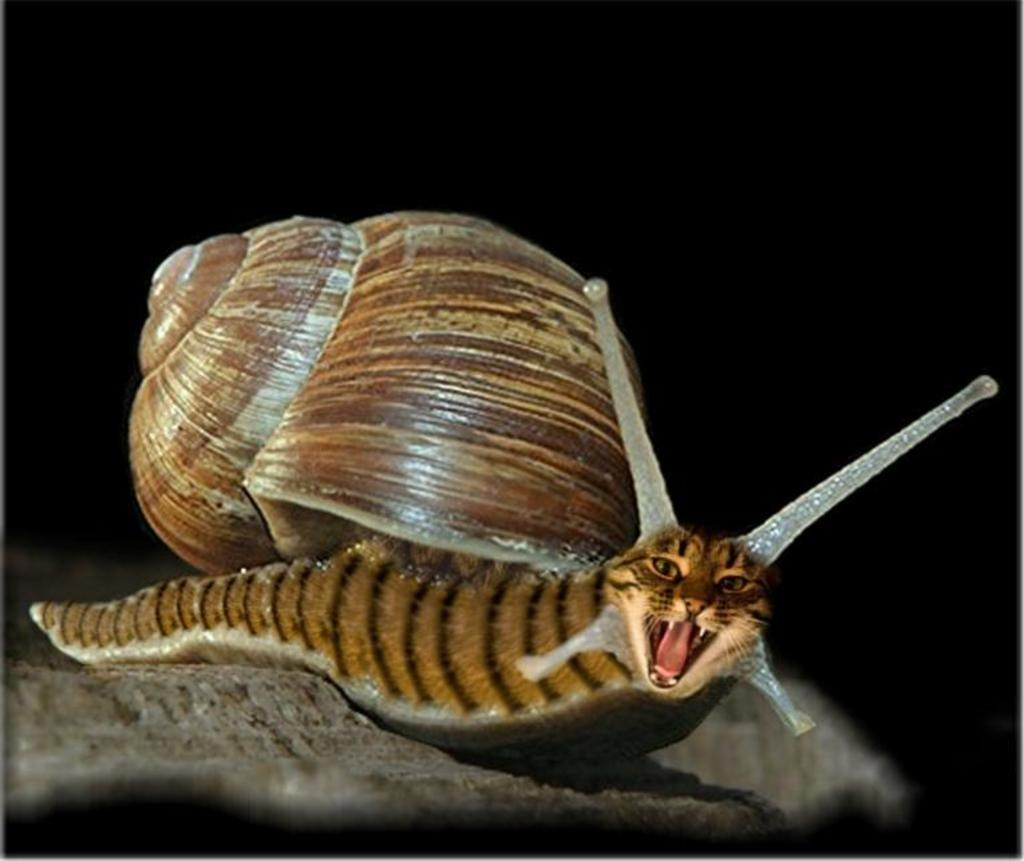What animal can be seen in the image? There is a snail on a rock in the image. What is the snail resting on? The snail is resting on a rock. What color is the background of the image? The background of the image is black. What type of treatment is the snail receiving in the image? There is no indication in the image that the snail is receiving any treatment. 